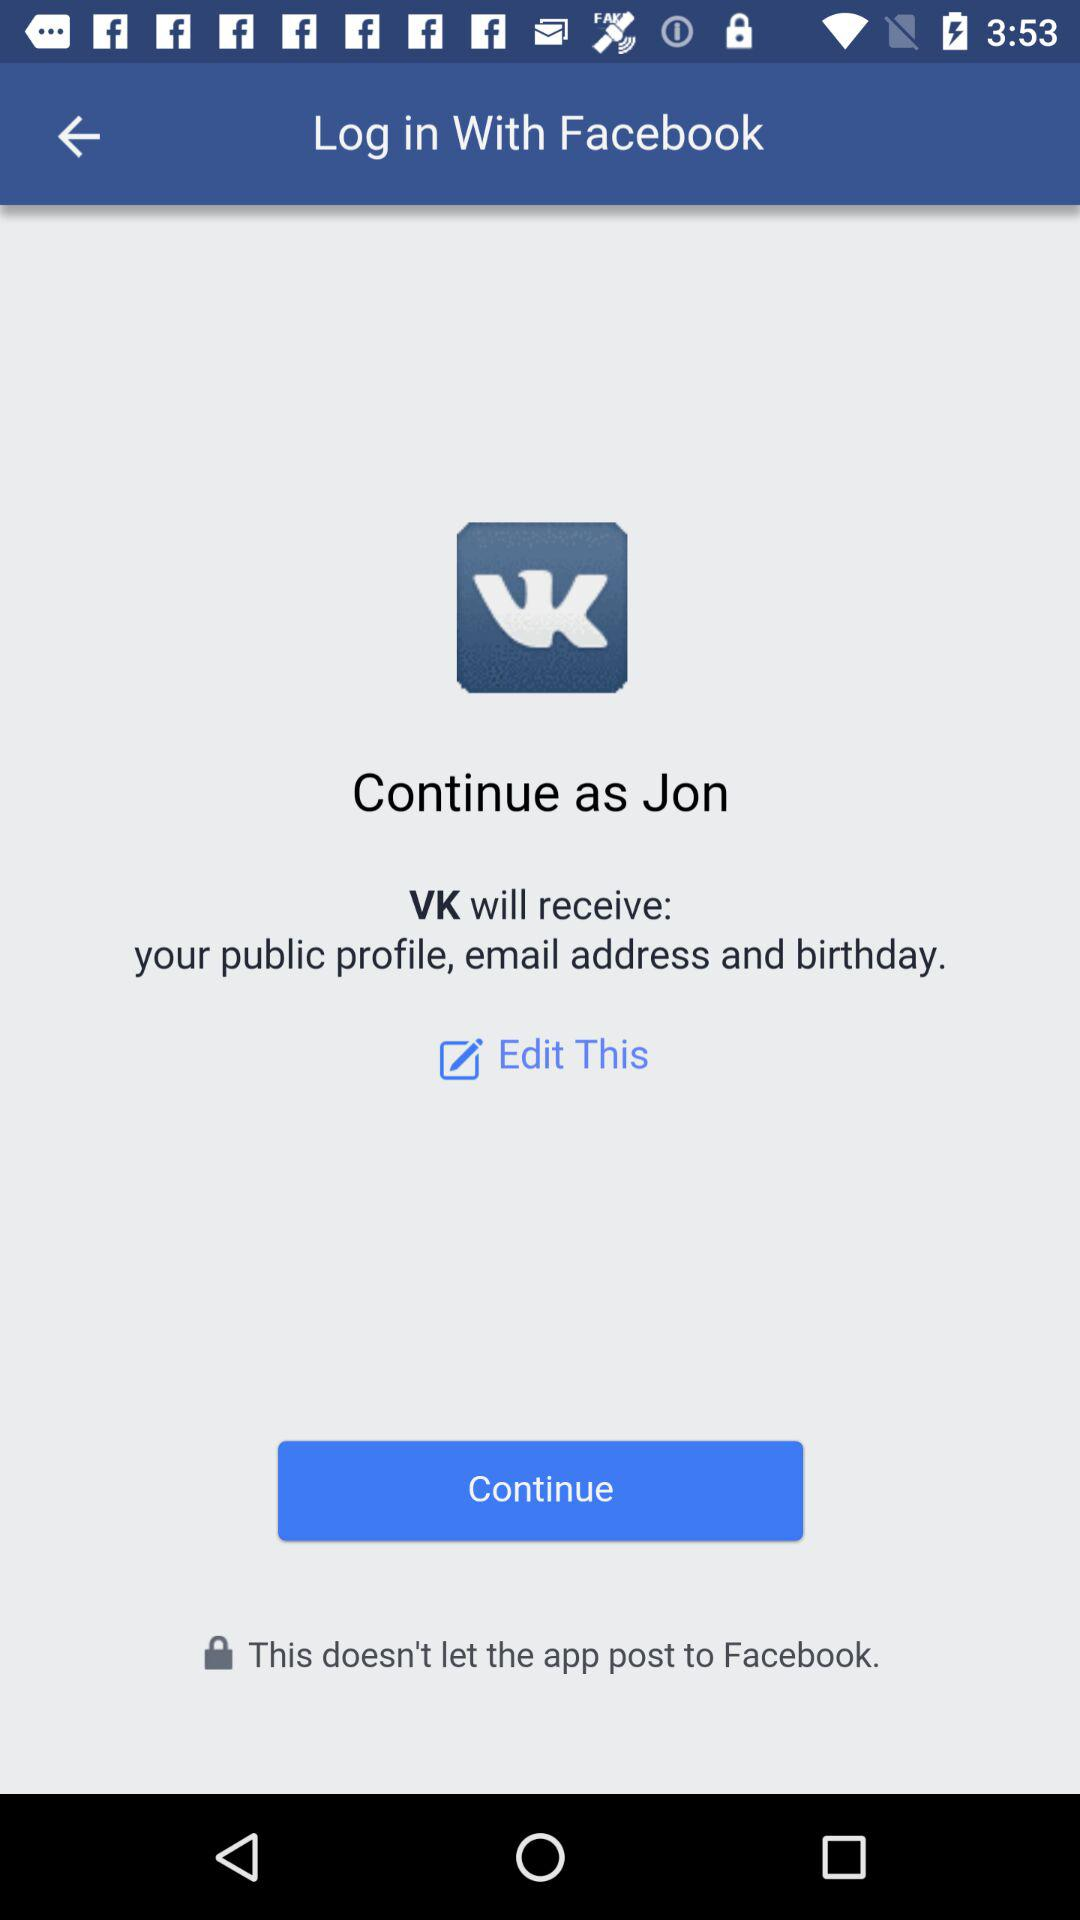What is the copyright year of "VK"?
When the provided information is insufficient, respond with <no answer>. <no answer> 